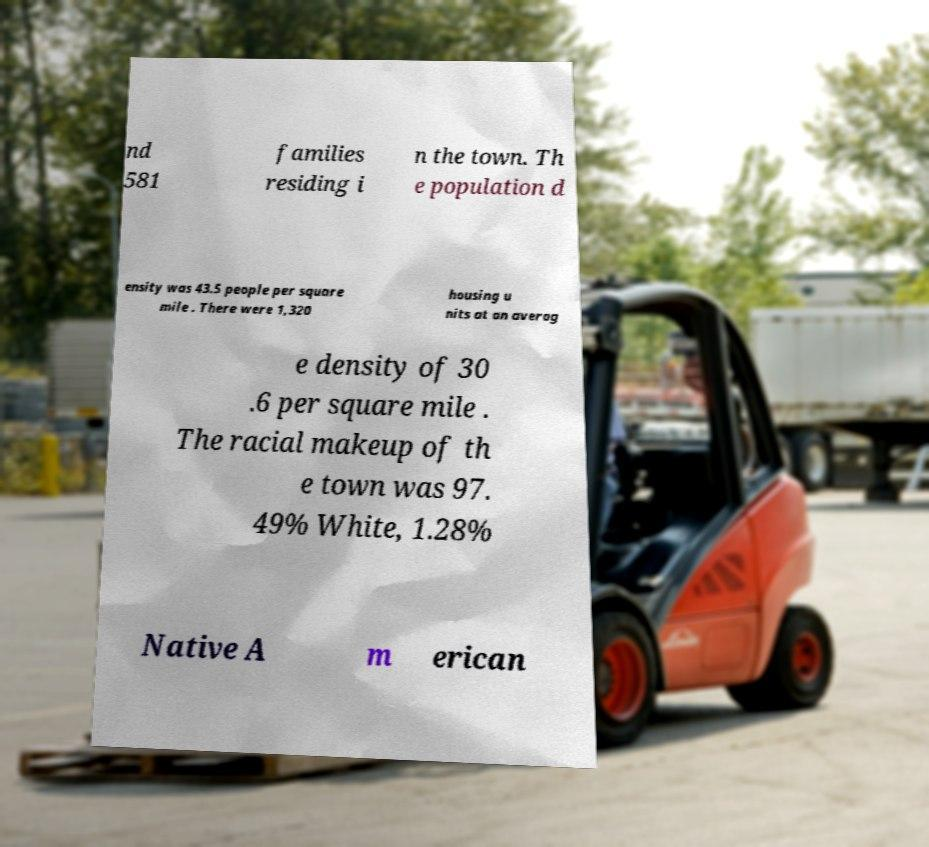Please identify and transcribe the text found in this image. nd 581 families residing i n the town. Th e population d ensity was 43.5 people per square mile . There were 1,320 housing u nits at an averag e density of 30 .6 per square mile . The racial makeup of th e town was 97. 49% White, 1.28% Native A m erican 